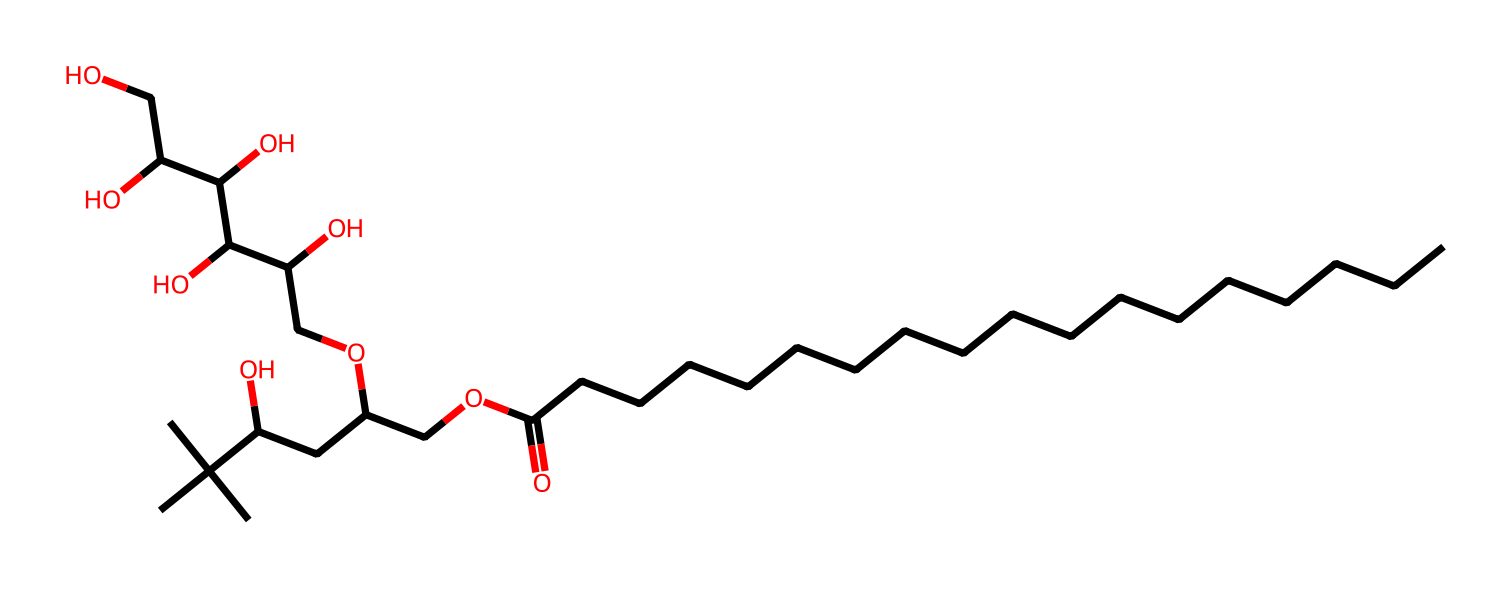What is the main functional group present in polysorbate 80? The main functional group in polysorbate 80 is the ester group, identifiable by the -COO- linkage present in the molecular structure.
Answer: ester How many carbon atoms are in the polysorbate 80 structure? By counting the carbons present in the linear and branched portions of the molecule, there are a total of 20 carbon atoms.
Answer: 20 Which segment of the molecule contributes to its emulsifying properties? The hydrophilic part of the molecule, particularly the polyol segment, helps reduce surface tension and facilitates emulsification.
Answer: polyol What type of surfactant is polysorbate 80 classified as? Polysorbate 80 is classified as a nonionic surfactant, which means it does not carry a charge and its behavior is based on its hydrophilic-lipophilic balance.
Answer: nonionic How many hydroxyl groups are present in the polysorbate 80 structure? By closely examining the structure, a total of 6 hydroxyl (-OH) groups can be identified in the molecule.
Answer: 6 